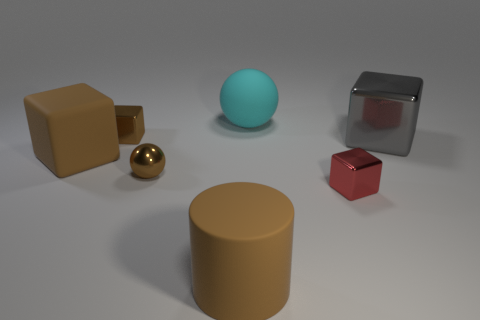Can you describe the lighting setup based on the shadows and reflections visible in the scene? The lighting in this scene seems to be coming from above, slightly to the front-left of the arrangement, as indicated by the direction of the shadows cast towards the back-right. The diffused nature of the shadows and the soft edges suggest the light source is not point-like but rather broad, likely a large overhead light or maybe a window out of the frame, providing a soft illumination without harsh highlights on the objects, except for the reflective surfaces of the metallic objects. 